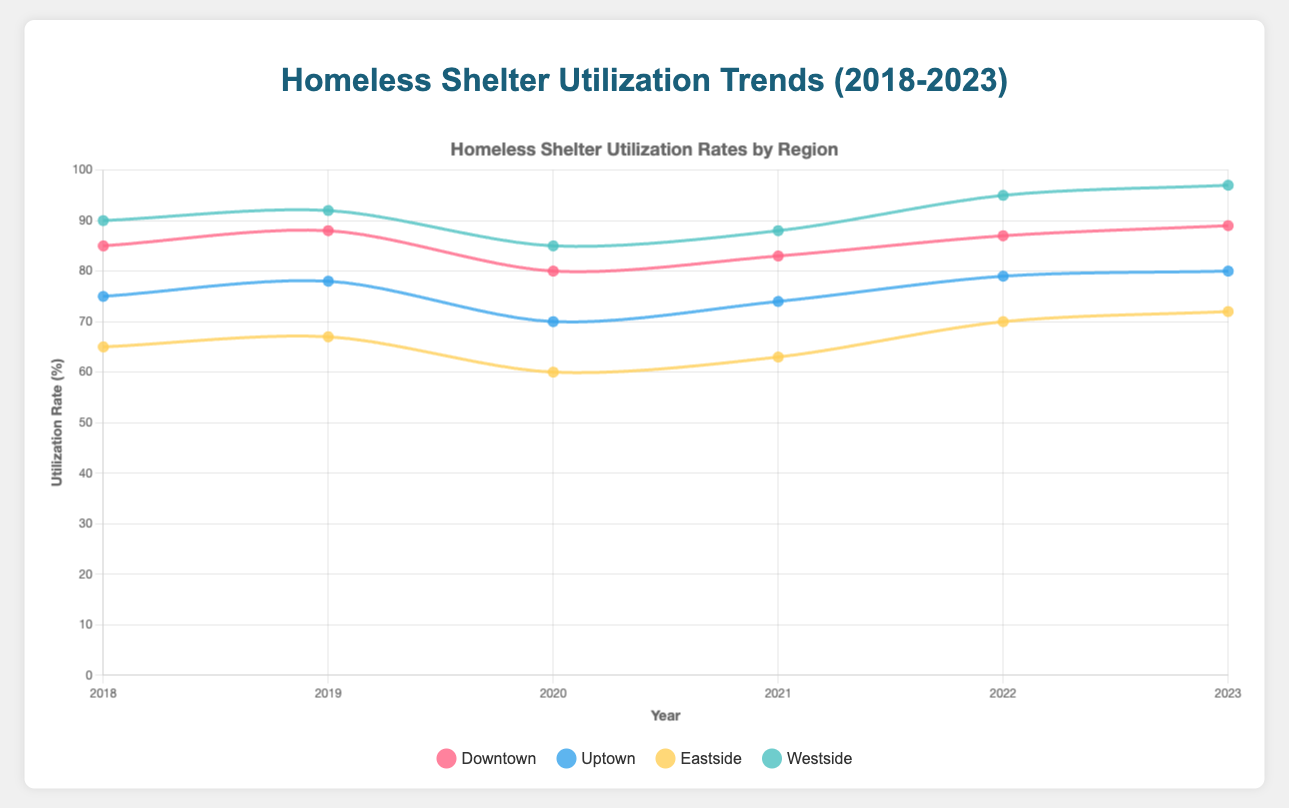Which region had the highest shelter utilization rate in 2020? To answer this, look for the highest data point for the year 2020 across all regions. The "Westside" region has the highest utilization rate at 85%.
Answer: Westside How did the utilization rate in Downtown change from 2018 to 2023? Identify and subtract the utilization rates of Downtown for 2018 and 2023. The rate changed from 85% in 2018 to 89% in 2023, an increase of 4%.
Answer: Increased by 4% What is the average utilization rate for Uptown over the 5 years? To find the average, sum the utilization rates for Uptown from 2018 to 2023 and then divide by the number of years. The sum is 75 + 78 + 70 + 74 + 79 + 80 = 456. The average is 456 / 6 ≈ 76%.
Answer: 76% Which year saw the highest utilization rate in Eastside? Check the data points for Eastside from 2018 to 2023 and find the maximum value. The highest rate is 72% in the year 2023.
Answer: 2023 Compare the available beds between Westside and Eastside in 2023. Look at the available beds for both Westside and Eastside in 2023. Westside had 145 beds, and Eastside had 110 beds. The difference is 145 - 110 = 35 beds more in Westside.
Answer: 35 beds more in Westside Calculate the total number of available beds in Downtown from 2018 to 2023. Sum the available beds for Downtown from 2018 to 2023: 150 + 160 + 140 + 145 + 155 + 160 = 910 beds.
Answer: 910 Which region had the most significant increase in shelter utilization rate from 2020 to 2023? Calculate the difference in utilization rates for each region from 2020 to 2023. Westside had the most significant increase from 85% in 2020 to 97% in 2023, an increase of 12%.
Answer: Westside In which year did the Uptown region have the lowest utilization rate and what was it? Check the data points for Uptown from 2018 to 2023 and find the minimum value. The lowest rate is 70% in the year 2020.
Answer: 2020 with 70% What is the trend in available beds in Eastside from 2018 to 2023? Analyze the available beds in Eastside from 2018 to 2023. The numbers are 80, 85, 90, 100, 105, and 110, showing a steady increase.
Answer: Increasing trend Which region had the highest utilization rate in 2023, and what was it? Look at the data points for all regions in 2023 and identify the highest value. Westside had the highest utilization rate at 97%.
Answer: Westside with 97% 